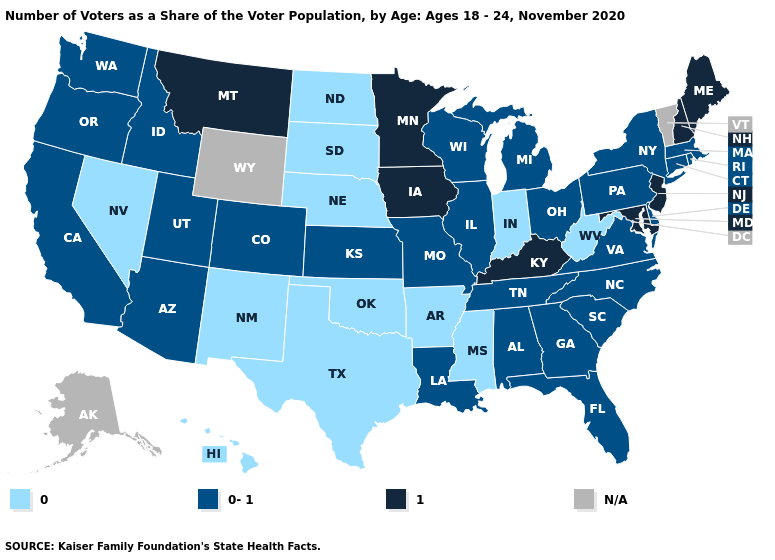Which states have the lowest value in the USA?
Give a very brief answer. Arkansas, Hawaii, Indiana, Mississippi, Nebraska, Nevada, New Mexico, North Dakota, Oklahoma, South Dakota, Texas, West Virginia. Name the states that have a value in the range 1?
Short answer required. Iowa, Kentucky, Maine, Maryland, Minnesota, Montana, New Hampshire, New Jersey. What is the value of Kansas?
Give a very brief answer. 0-1. What is the value of Massachusetts?
Give a very brief answer. 0-1. What is the value of Delaware?
Concise answer only. 0-1. Which states have the lowest value in the USA?
Be succinct. Arkansas, Hawaii, Indiana, Mississippi, Nebraska, Nevada, New Mexico, North Dakota, Oklahoma, South Dakota, Texas, West Virginia. Among the states that border Connecticut , which have the highest value?
Answer briefly. Massachusetts, New York, Rhode Island. Which states have the highest value in the USA?
Be succinct. Iowa, Kentucky, Maine, Maryland, Minnesota, Montana, New Hampshire, New Jersey. What is the lowest value in the MidWest?
Write a very short answer. 0. What is the lowest value in the USA?
Short answer required. 0. Does the map have missing data?
Short answer required. Yes. What is the value of Illinois?
Short answer required. 0-1. Name the states that have a value in the range 0?
Quick response, please. Arkansas, Hawaii, Indiana, Mississippi, Nebraska, Nevada, New Mexico, North Dakota, Oklahoma, South Dakota, Texas, West Virginia. Does Connecticut have the highest value in the Northeast?
Concise answer only. No. 